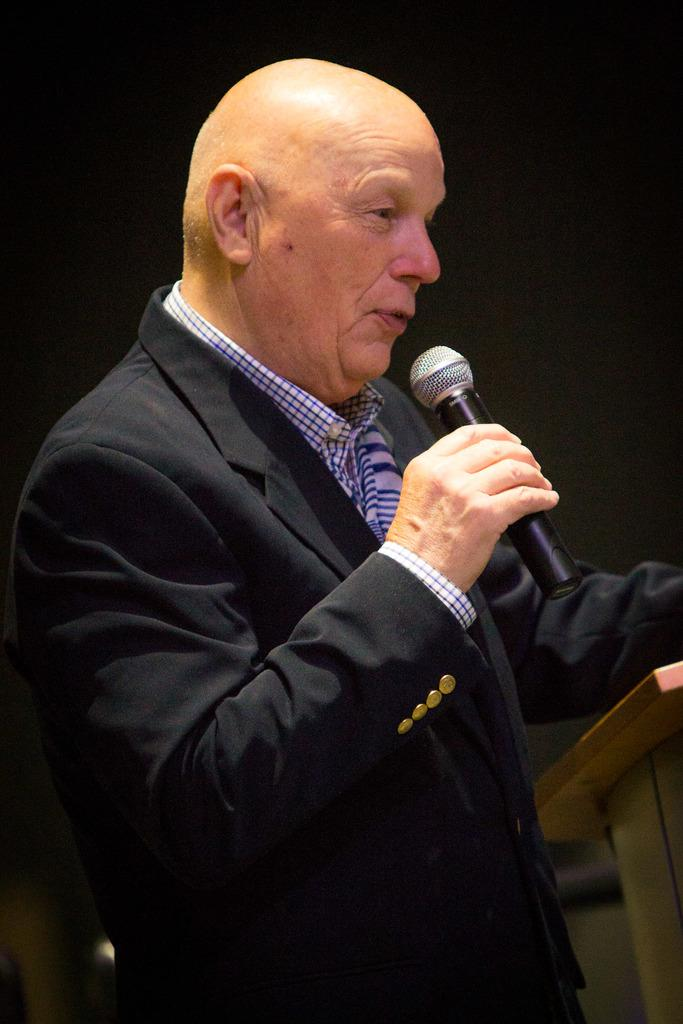Who is the main subject in the image? There is a man in the image. What is the man doing in the image? The man is standing near a podium. What object is the man holding in his hand? The man is holding a mic in his hand. What type of shake is the man exchanging with the audience in the image? There is no shake or exchange of any kind happening in the image; the man is simply standing near a podium and holding a mic. 